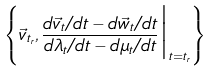Convert formula to latex. <formula><loc_0><loc_0><loc_500><loc_500>\left \{ \vec { v } _ { t _ { r } } , \frac { d \vec { v } _ { t } / d t - d \vec { w } _ { t } / d t } { d \lambda _ { t } / d t - d \mu _ { t } / d t } \Big | _ { t = t _ { r } } \right \}</formula> 